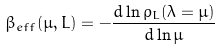Convert formula to latex. <formula><loc_0><loc_0><loc_500><loc_500>\beta _ { e f f } ( \mu , L ) = - \frac { d \ln \rho _ { L } ( \lambda = \mu ) } { d \ln \mu }</formula> 